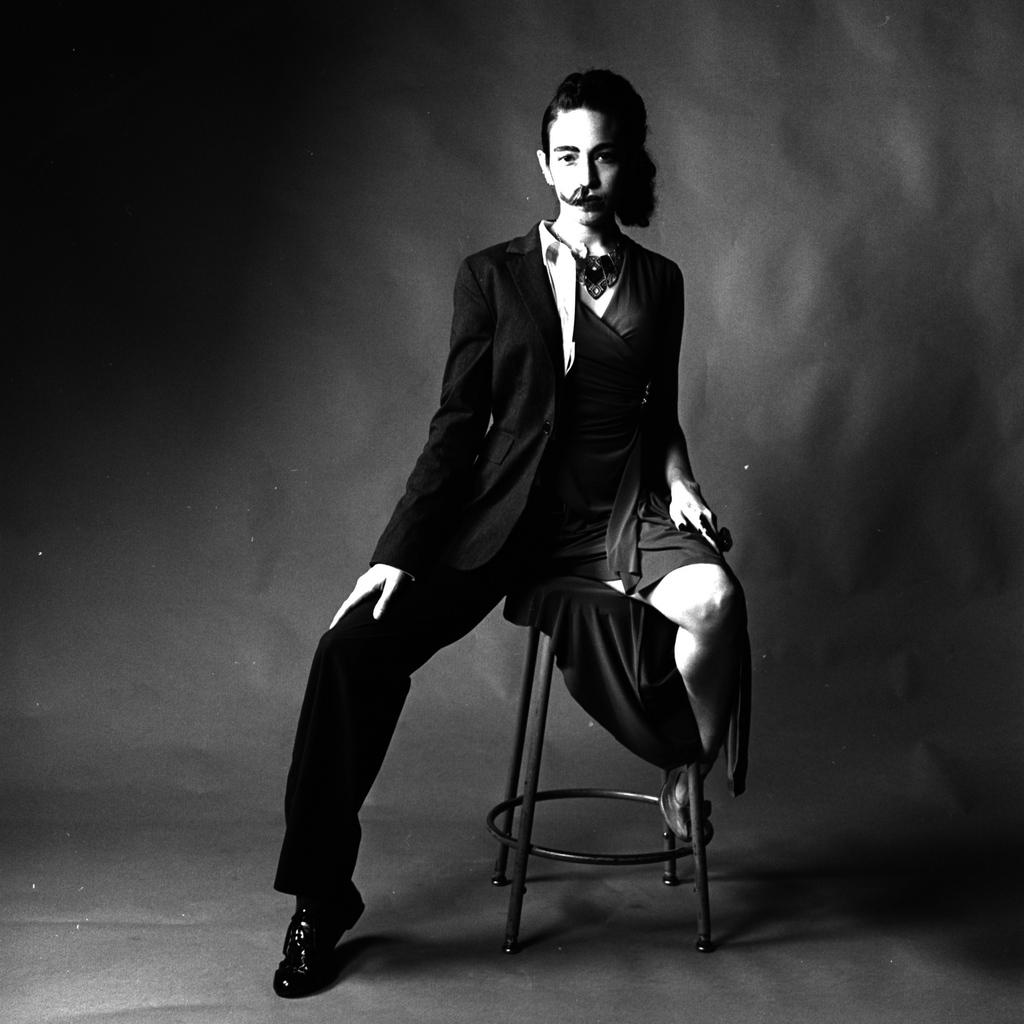What is the main subject of the image? There is a person in the image. How is the person dressed in the image? The person is dressed up half as a man and half as a woman. What is the person sitting on in the image? The person is sitting on a stool. What can be observed about the background of the image? The background of the image is dark. How many icicles are hanging from the person's clothing in the image? There are no icicles present in the image. What type of government policy is being discussed in the image? There is no discussion of government policy in the image; it features a person dressed up half as a man and half as a woman, sitting on a stool with a dark background. 